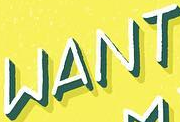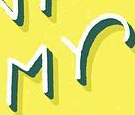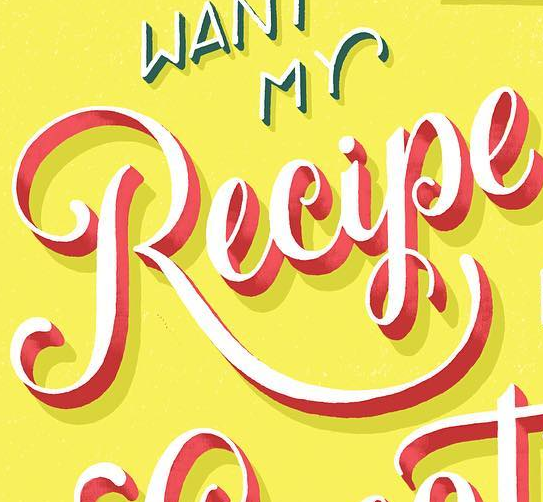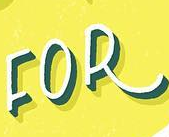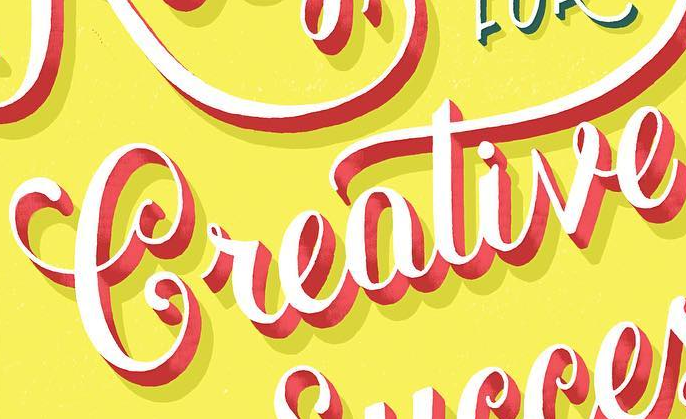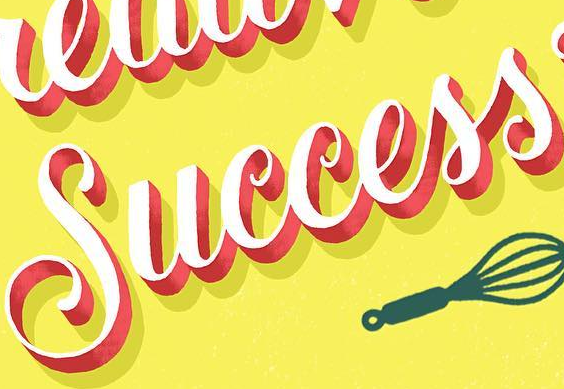What text is displayed in these images sequentially, separated by a semicolon? WANT; MY; Recipe; FOR; Creative; Success 